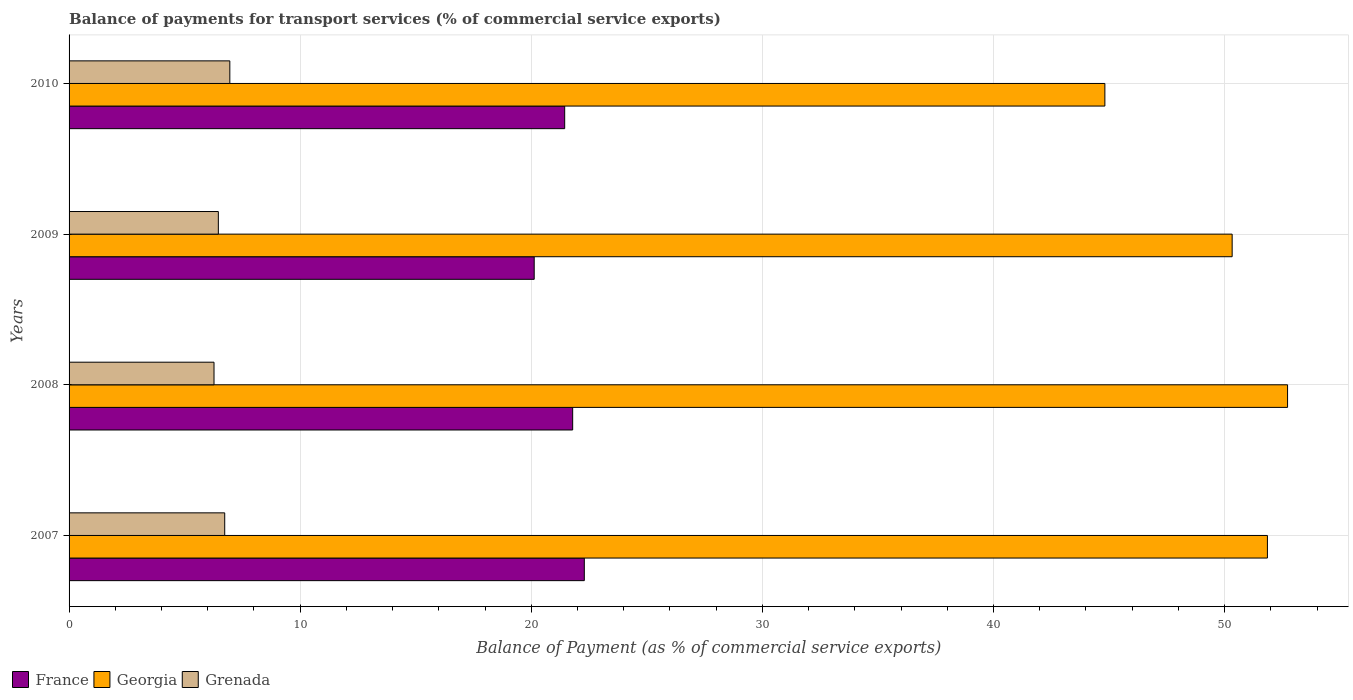How many different coloured bars are there?
Ensure brevity in your answer.  3. Are the number of bars on each tick of the Y-axis equal?
Ensure brevity in your answer.  Yes. How many bars are there on the 2nd tick from the top?
Give a very brief answer. 3. How many bars are there on the 4th tick from the bottom?
Your answer should be compact. 3. What is the balance of payments for transport services in France in 2010?
Your response must be concise. 21.45. Across all years, what is the maximum balance of payments for transport services in Georgia?
Make the answer very short. 52.72. Across all years, what is the minimum balance of payments for transport services in Grenada?
Offer a terse response. 6.27. In which year was the balance of payments for transport services in Georgia maximum?
Offer a terse response. 2008. In which year was the balance of payments for transport services in Grenada minimum?
Provide a short and direct response. 2008. What is the total balance of payments for transport services in France in the graph?
Offer a terse response. 85.66. What is the difference between the balance of payments for transport services in France in 2008 and that in 2010?
Keep it short and to the point. 0.35. What is the difference between the balance of payments for transport services in France in 2010 and the balance of payments for transport services in Grenada in 2008?
Keep it short and to the point. 15.17. What is the average balance of payments for transport services in Grenada per year?
Your answer should be compact. 6.61. In the year 2010, what is the difference between the balance of payments for transport services in Grenada and balance of payments for transport services in Georgia?
Your answer should be compact. -37.86. What is the ratio of the balance of payments for transport services in Georgia in 2008 to that in 2010?
Provide a short and direct response. 1.18. What is the difference between the highest and the second highest balance of payments for transport services in Georgia?
Provide a succinct answer. 0.87. What is the difference between the highest and the lowest balance of payments for transport services in Grenada?
Your answer should be compact. 0.68. What does the 3rd bar from the top in 2007 represents?
Your response must be concise. France. What does the 2nd bar from the bottom in 2008 represents?
Make the answer very short. Georgia. Is it the case that in every year, the sum of the balance of payments for transport services in France and balance of payments for transport services in Grenada is greater than the balance of payments for transport services in Georgia?
Ensure brevity in your answer.  No. Are all the bars in the graph horizontal?
Offer a very short reply. Yes. What is the difference between two consecutive major ticks on the X-axis?
Ensure brevity in your answer.  10. Are the values on the major ticks of X-axis written in scientific E-notation?
Ensure brevity in your answer.  No. Does the graph contain grids?
Make the answer very short. Yes. How many legend labels are there?
Offer a terse response. 3. What is the title of the graph?
Give a very brief answer. Balance of payments for transport services (% of commercial service exports). Does "Luxembourg" appear as one of the legend labels in the graph?
Offer a terse response. No. What is the label or title of the X-axis?
Ensure brevity in your answer.  Balance of Payment (as % of commercial service exports). What is the label or title of the Y-axis?
Provide a succinct answer. Years. What is the Balance of Payment (as % of commercial service exports) of France in 2007?
Your answer should be very brief. 22.29. What is the Balance of Payment (as % of commercial service exports) of Georgia in 2007?
Make the answer very short. 51.85. What is the Balance of Payment (as % of commercial service exports) of Grenada in 2007?
Offer a terse response. 6.73. What is the Balance of Payment (as % of commercial service exports) in France in 2008?
Keep it short and to the point. 21.79. What is the Balance of Payment (as % of commercial service exports) in Georgia in 2008?
Your answer should be very brief. 52.72. What is the Balance of Payment (as % of commercial service exports) of Grenada in 2008?
Your response must be concise. 6.27. What is the Balance of Payment (as % of commercial service exports) of France in 2009?
Provide a succinct answer. 20.13. What is the Balance of Payment (as % of commercial service exports) of Georgia in 2009?
Ensure brevity in your answer.  50.33. What is the Balance of Payment (as % of commercial service exports) in Grenada in 2009?
Offer a very short reply. 6.46. What is the Balance of Payment (as % of commercial service exports) in France in 2010?
Your answer should be very brief. 21.45. What is the Balance of Payment (as % of commercial service exports) of Georgia in 2010?
Your answer should be very brief. 44.82. What is the Balance of Payment (as % of commercial service exports) in Grenada in 2010?
Your response must be concise. 6.96. Across all years, what is the maximum Balance of Payment (as % of commercial service exports) of France?
Offer a very short reply. 22.29. Across all years, what is the maximum Balance of Payment (as % of commercial service exports) of Georgia?
Your answer should be compact. 52.72. Across all years, what is the maximum Balance of Payment (as % of commercial service exports) of Grenada?
Make the answer very short. 6.96. Across all years, what is the minimum Balance of Payment (as % of commercial service exports) in France?
Provide a short and direct response. 20.13. Across all years, what is the minimum Balance of Payment (as % of commercial service exports) of Georgia?
Your answer should be compact. 44.82. Across all years, what is the minimum Balance of Payment (as % of commercial service exports) in Grenada?
Ensure brevity in your answer.  6.27. What is the total Balance of Payment (as % of commercial service exports) of France in the graph?
Offer a very short reply. 85.66. What is the total Balance of Payment (as % of commercial service exports) in Georgia in the graph?
Your response must be concise. 199.72. What is the total Balance of Payment (as % of commercial service exports) in Grenada in the graph?
Your response must be concise. 26.42. What is the difference between the Balance of Payment (as % of commercial service exports) in France in 2007 and that in 2008?
Your answer should be compact. 0.5. What is the difference between the Balance of Payment (as % of commercial service exports) of Georgia in 2007 and that in 2008?
Your response must be concise. -0.87. What is the difference between the Balance of Payment (as % of commercial service exports) in Grenada in 2007 and that in 2008?
Your answer should be compact. 0.46. What is the difference between the Balance of Payment (as % of commercial service exports) in France in 2007 and that in 2009?
Offer a terse response. 2.17. What is the difference between the Balance of Payment (as % of commercial service exports) of Georgia in 2007 and that in 2009?
Offer a very short reply. 1.53. What is the difference between the Balance of Payment (as % of commercial service exports) in Grenada in 2007 and that in 2009?
Your answer should be very brief. 0.28. What is the difference between the Balance of Payment (as % of commercial service exports) in France in 2007 and that in 2010?
Offer a terse response. 0.85. What is the difference between the Balance of Payment (as % of commercial service exports) in Georgia in 2007 and that in 2010?
Offer a terse response. 7.03. What is the difference between the Balance of Payment (as % of commercial service exports) of Grenada in 2007 and that in 2010?
Provide a succinct answer. -0.22. What is the difference between the Balance of Payment (as % of commercial service exports) of France in 2008 and that in 2009?
Offer a very short reply. 1.66. What is the difference between the Balance of Payment (as % of commercial service exports) of Georgia in 2008 and that in 2009?
Your response must be concise. 2.4. What is the difference between the Balance of Payment (as % of commercial service exports) of Grenada in 2008 and that in 2009?
Make the answer very short. -0.19. What is the difference between the Balance of Payment (as % of commercial service exports) in France in 2008 and that in 2010?
Give a very brief answer. 0.35. What is the difference between the Balance of Payment (as % of commercial service exports) of Georgia in 2008 and that in 2010?
Provide a short and direct response. 7.9. What is the difference between the Balance of Payment (as % of commercial service exports) of Grenada in 2008 and that in 2010?
Your answer should be very brief. -0.68. What is the difference between the Balance of Payment (as % of commercial service exports) in France in 2009 and that in 2010?
Give a very brief answer. -1.32. What is the difference between the Balance of Payment (as % of commercial service exports) of Georgia in 2009 and that in 2010?
Keep it short and to the point. 5.51. What is the difference between the Balance of Payment (as % of commercial service exports) of Grenada in 2009 and that in 2010?
Keep it short and to the point. -0.5. What is the difference between the Balance of Payment (as % of commercial service exports) in France in 2007 and the Balance of Payment (as % of commercial service exports) in Georgia in 2008?
Keep it short and to the point. -30.43. What is the difference between the Balance of Payment (as % of commercial service exports) in France in 2007 and the Balance of Payment (as % of commercial service exports) in Grenada in 2008?
Make the answer very short. 16.02. What is the difference between the Balance of Payment (as % of commercial service exports) in Georgia in 2007 and the Balance of Payment (as % of commercial service exports) in Grenada in 2008?
Make the answer very short. 45.58. What is the difference between the Balance of Payment (as % of commercial service exports) of France in 2007 and the Balance of Payment (as % of commercial service exports) of Georgia in 2009?
Your answer should be very brief. -28.03. What is the difference between the Balance of Payment (as % of commercial service exports) of France in 2007 and the Balance of Payment (as % of commercial service exports) of Grenada in 2009?
Give a very brief answer. 15.84. What is the difference between the Balance of Payment (as % of commercial service exports) in Georgia in 2007 and the Balance of Payment (as % of commercial service exports) in Grenada in 2009?
Offer a very short reply. 45.39. What is the difference between the Balance of Payment (as % of commercial service exports) of France in 2007 and the Balance of Payment (as % of commercial service exports) of Georgia in 2010?
Your response must be concise. -22.52. What is the difference between the Balance of Payment (as % of commercial service exports) in France in 2007 and the Balance of Payment (as % of commercial service exports) in Grenada in 2010?
Your answer should be very brief. 15.34. What is the difference between the Balance of Payment (as % of commercial service exports) in Georgia in 2007 and the Balance of Payment (as % of commercial service exports) in Grenada in 2010?
Your answer should be very brief. 44.9. What is the difference between the Balance of Payment (as % of commercial service exports) in France in 2008 and the Balance of Payment (as % of commercial service exports) in Georgia in 2009?
Your answer should be very brief. -28.54. What is the difference between the Balance of Payment (as % of commercial service exports) in France in 2008 and the Balance of Payment (as % of commercial service exports) in Grenada in 2009?
Offer a very short reply. 15.33. What is the difference between the Balance of Payment (as % of commercial service exports) of Georgia in 2008 and the Balance of Payment (as % of commercial service exports) of Grenada in 2009?
Keep it short and to the point. 46.27. What is the difference between the Balance of Payment (as % of commercial service exports) in France in 2008 and the Balance of Payment (as % of commercial service exports) in Georgia in 2010?
Your answer should be very brief. -23.03. What is the difference between the Balance of Payment (as % of commercial service exports) of France in 2008 and the Balance of Payment (as % of commercial service exports) of Grenada in 2010?
Ensure brevity in your answer.  14.83. What is the difference between the Balance of Payment (as % of commercial service exports) of Georgia in 2008 and the Balance of Payment (as % of commercial service exports) of Grenada in 2010?
Offer a very short reply. 45.77. What is the difference between the Balance of Payment (as % of commercial service exports) in France in 2009 and the Balance of Payment (as % of commercial service exports) in Georgia in 2010?
Give a very brief answer. -24.69. What is the difference between the Balance of Payment (as % of commercial service exports) of France in 2009 and the Balance of Payment (as % of commercial service exports) of Grenada in 2010?
Keep it short and to the point. 13.17. What is the difference between the Balance of Payment (as % of commercial service exports) of Georgia in 2009 and the Balance of Payment (as % of commercial service exports) of Grenada in 2010?
Offer a terse response. 43.37. What is the average Balance of Payment (as % of commercial service exports) of France per year?
Offer a very short reply. 21.41. What is the average Balance of Payment (as % of commercial service exports) in Georgia per year?
Make the answer very short. 49.93. What is the average Balance of Payment (as % of commercial service exports) of Grenada per year?
Your response must be concise. 6.61. In the year 2007, what is the difference between the Balance of Payment (as % of commercial service exports) of France and Balance of Payment (as % of commercial service exports) of Georgia?
Your response must be concise. -29.56. In the year 2007, what is the difference between the Balance of Payment (as % of commercial service exports) in France and Balance of Payment (as % of commercial service exports) in Grenada?
Your answer should be compact. 15.56. In the year 2007, what is the difference between the Balance of Payment (as % of commercial service exports) in Georgia and Balance of Payment (as % of commercial service exports) in Grenada?
Your answer should be very brief. 45.12. In the year 2008, what is the difference between the Balance of Payment (as % of commercial service exports) of France and Balance of Payment (as % of commercial service exports) of Georgia?
Ensure brevity in your answer.  -30.93. In the year 2008, what is the difference between the Balance of Payment (as % of commercial service exports) in France and Balance of Payment (as % of commercial service exports) in Grenada?
Keep it short and to the point. 15.52. In the year 2008, what is the difference between the Balance of Payment (as % of commercial service exports) in Georgia and Balance of Payment (as % of commercial service exports) in Grenada?
Ensure brevity in your answer.  46.45. In the year 2009, what is the difference between the Balance of Payment (as % of commercial service exports) of France and Balance of Payment (as % of commercial service exports) of Georgia?
Offer a terse response. -30.2. In the year 2009, what is the difference between the Balance of Payment (as % of commercial service exports) in France and Balance of Payment (as % of commercial service exports) in Grenada?
Give a very brief answer. 13.67. In the year 2009, what is the difference between the Balance of Payment (as % of commercial service exports) of Georgia and Balance of Payment (as % of commercial service exports) of Grenada?
Make the answer very short. 43.87. In the year 2010, what is the difference between the Balance of Payment (as % of commercial service exports) in France and Balance of Payment (as % of commercial service exports) in Georgia?
Provide a short and direct response. -23.37. In the year 2010, what is the difference between the Balance of Payment (as % of commercial service exports) of France and Balance of Payment (as % of commercial service exports) of Grenada?
Your response must be concise. 14.49. In the year 2010, what is the difference between the Balance of Payment (as % of commercial service exports) of Georgia and Balance of Payment (as % of commercial service exports) of Grenada?
Your answer should be compact. 37.86. What is the ratio of the Balance of Payment (as % of commercial service exports) in France in 2007 to that in 2008?
Offer a terse response. 1.02. What is the ratio of the Balance of Payment (as % of commercial service exports) in Georgia in 2007 to that in 2008?
Keep it short and to the point. 0.98. What is the ratio of the Balance of Payment (as % of commercial service exports) of Grenada in 2007 to that in 2008?
Your answer should be very brief. 1.07. What is the ratio of the Balance of Payment (as % of commercial service exports) of France in 2007 to that in 2009?
Give a very brief answer. 1.11. What is the ratio of the Balance of Payment (as % of commercial service exports) in Georgia in 2007 to that in 2009?
Provide a short and direct response. 1.03. What is the ratio of the Balance of Payment (as % of commercial service exports) in Grenada in 2007 to that in 2009?
Offer a terse response. 1.04. What is the ratio of the Balance of Payment (as % of commercial service exports) of France in 2007 to that in 2010?
Keep it short and to the point. 1.04. What is the ratio of the Balance of Payment (as % of commercial service exports) in Georgia in 2007 to that in 2010?
Provide a short and direct response. 1.16. What is the ratio of the Balance of Payment (as % of commercial service exports) in Grenada in 2007 to that in 2010?
Provide a succinct answer. 0.97. What is the ratio of the Balance of Payment (as % of commercial service exports) in France in 2008 to that in 2009?
Give a very brief answer. 1.08. What is the ratio of the Balance of Payment (as % of commercial service exports) in Georgia in 2008 to that in 2009?
Your answer should be very brief. 1.05. What is the ratio of the Balance of Payment (as % of commercial service exports) in France in 2008 to that in 2010?
Give a very brief answer. 1.02. What is the ratio of the Balance of Payment (as % of commercial service exports) in Georgia in 2008 to that in 2010?
Your response must be concise. 1.18. What is the ratio of the Balance of Payment (as % of commercial service exports) in Grenada in 2008 to that in 2010?
Provide a succinct answer. 0.9. What is the ratio of the Balance of Payment (as % of commercial service exports) in France in 2009 to that in 2010?
Ensure brevity in your answer.  0.94. What is the ratio of the Balance of Payment (as % of commercial service exports) in Georgia in 2009 to that in 2010?
Provide a short and direct response. 1.12. What is the ratio of the Balance of Payment (as % of commercial service exports) in Grenada in 2009 to that in 2010?
Your answer should be very brief. 0.93. What is the difference between the highest and the second highest Balance of Payment (as % of commercial service exports) of France?
Your answer should be very brief. 0.5. What is the difference between the highest and the second highest Balance of Payment (as % of commercial service exports) of Georgia?
Your answer should be compact. 0.87. What is the difference between the highest and the second highest Balance of Payment (as % of commercial service exports) in Grenada?
Ensure brevity in your answer.  0.22. What is the difference between the highest and the lowest Balance of Payment (as % of commercial service exports) of France?
Give a very brief answer. 2.17. What is the difference between the highest and the lowest Balance of Payment (as % of commercial service exports) in Georgia?
Provide a succinct answer. 7.9. What is the difference between the highest and the lowest Balance of Payment (as % of commercial service exports) of Grenada?
Provide a succinct answer. 0.68. 